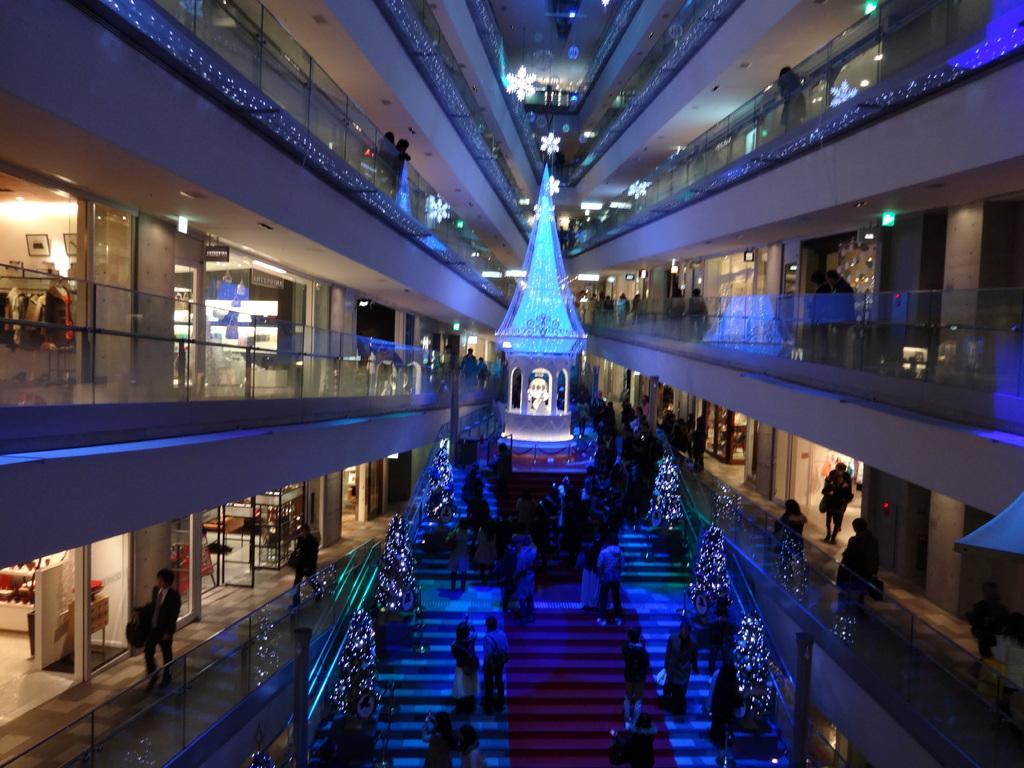How would you summarize this image in a sentence or two? In this picture I can see the inside view of a building, there are shops, there are group of people standing, there are lights, clothes, boards, there are trees decorated with lights, it looks like a show piece in the center of the image. 